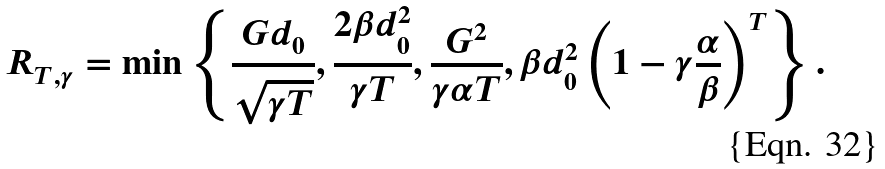<formula> <loc_0><loc_0><loc_500><loc_500>R _ { T , \gamma } = \min \left \{ \frac { G d _ { 0 } } { \sqrt { \gamma T } } , \frac { 2 \beta d _ { 0 } ^ { 2 } } { \gamma T } , \frac { G ^ { 2 } } { { \gamma } \alpha T } , \beta d _ { 0 } ^ { 2 } \left ( 1 - \gamma \frac { \alpha } { \beta } \right ) ^ { T } \right \} .</formula> 